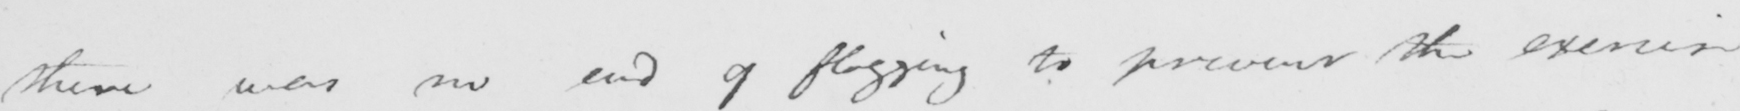Transcribe the text shown in this historical manuscript line. there was no end of flogging to prevent the exercise 